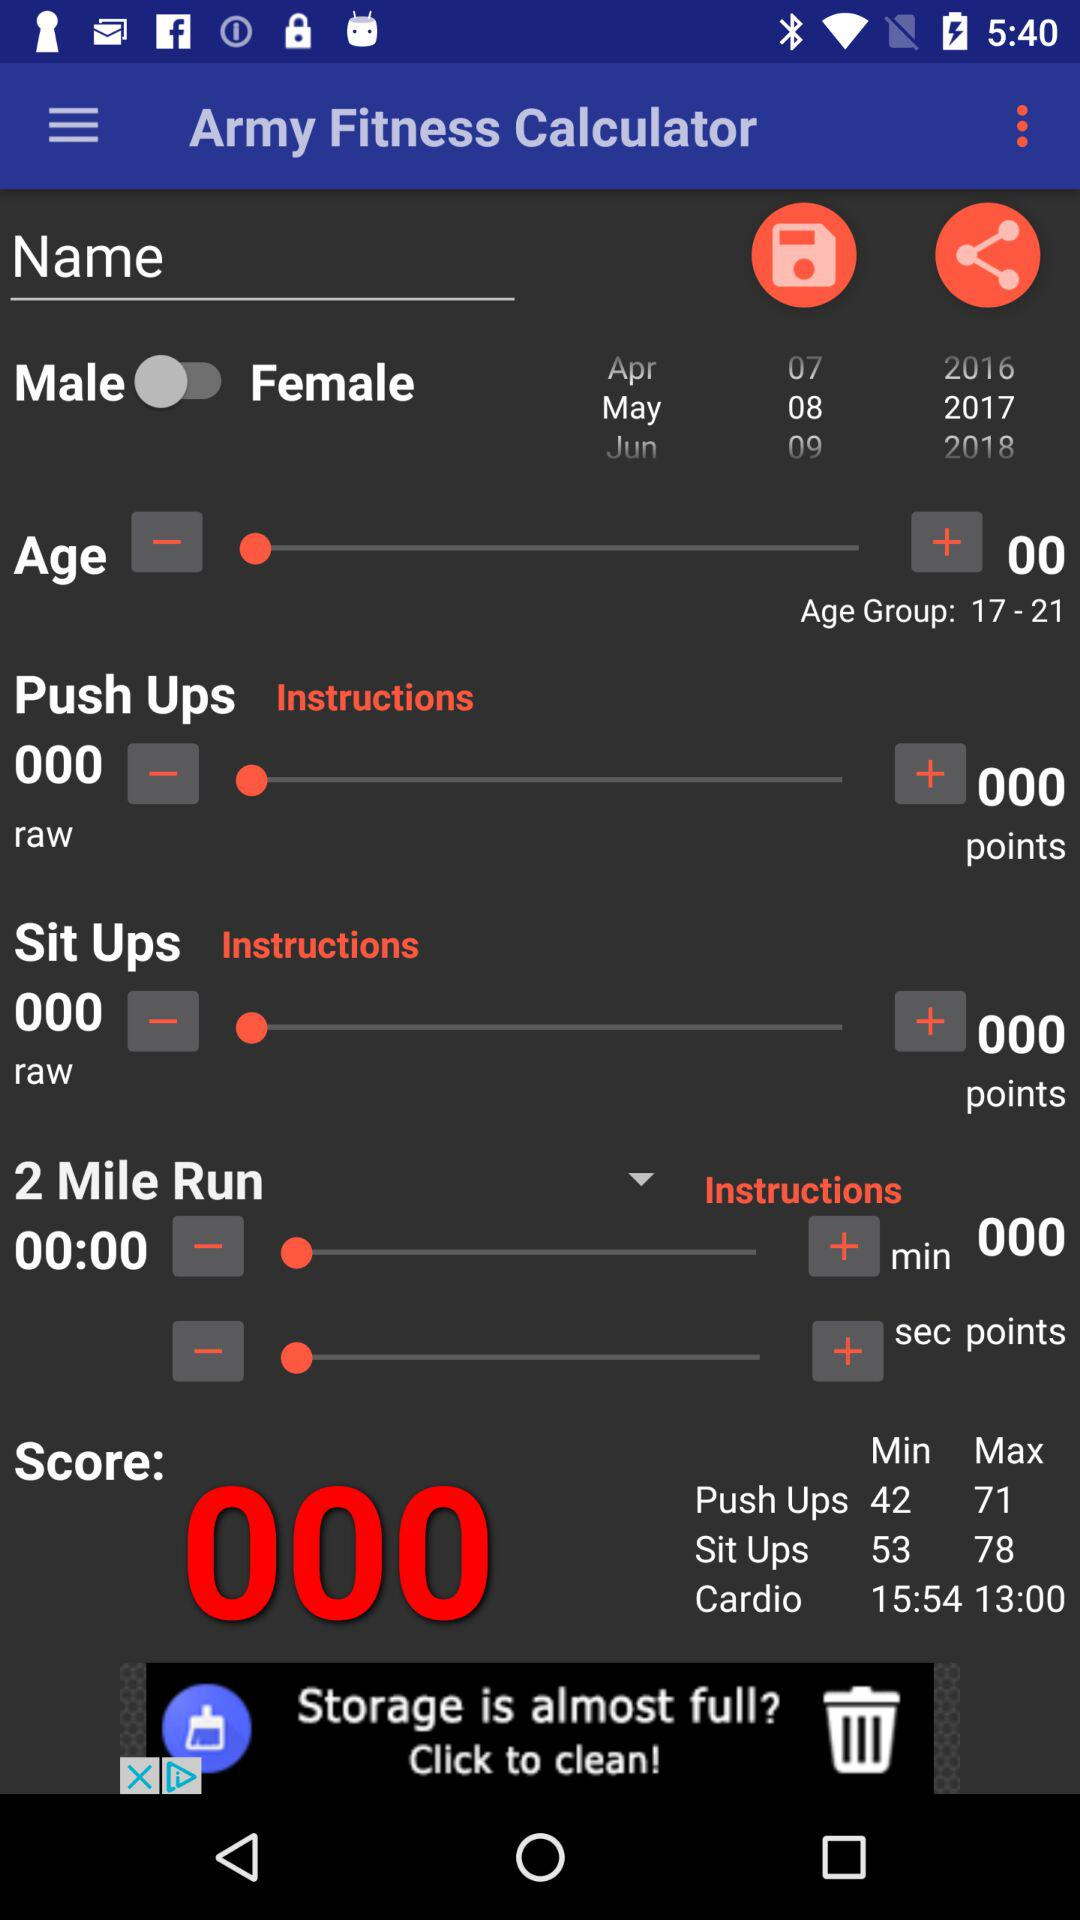What is the score? The score is 000. 